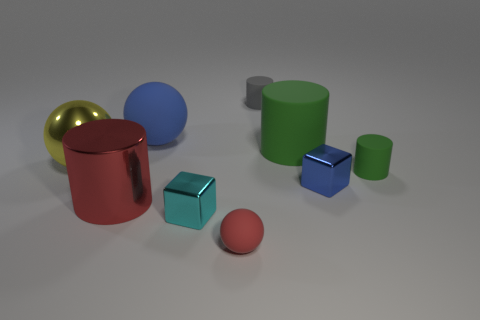Are there fewer small red spheres that are behind the blue metal thing than yellow spheres?
Provide a succinct answer. Yes. Is there anything else that has the same shape as the small green thing?
Provide a succinct answer. Yes. What is the color of the other thing that is the same shape as the tiny blue object?
Offer a terse response. Cyan. There is a rubber ball that is on the left side of the cyan cube; does it have the same size as the big yellow metallic object?
Offer a very short reply. Yes. How big is the blue object that is in front of the large rubber object that is on the right side of the small gray cylinder?
Offer a terse response. Small. Is the material of the large blue sphere the same as the blue object right of the small red ball?
Your response must be concise. No. Is the number of big spheres in front of the tiny red sphere less than the number of big green rubber cylinders in front of the yellow sphere?
Offer a very short reply. No. What is the color of the small ball that is made of the same material as the small green thing?
Give a very brief answer. Red. Are there any metallic cubes on the right side of the large cylinder that is in front of the small blue metal cube?
Ensure brevity in your answer.  Yes. What color is the metallic cylinder that is the same size as the yellow ball?
Give a very brief answer. Red. 